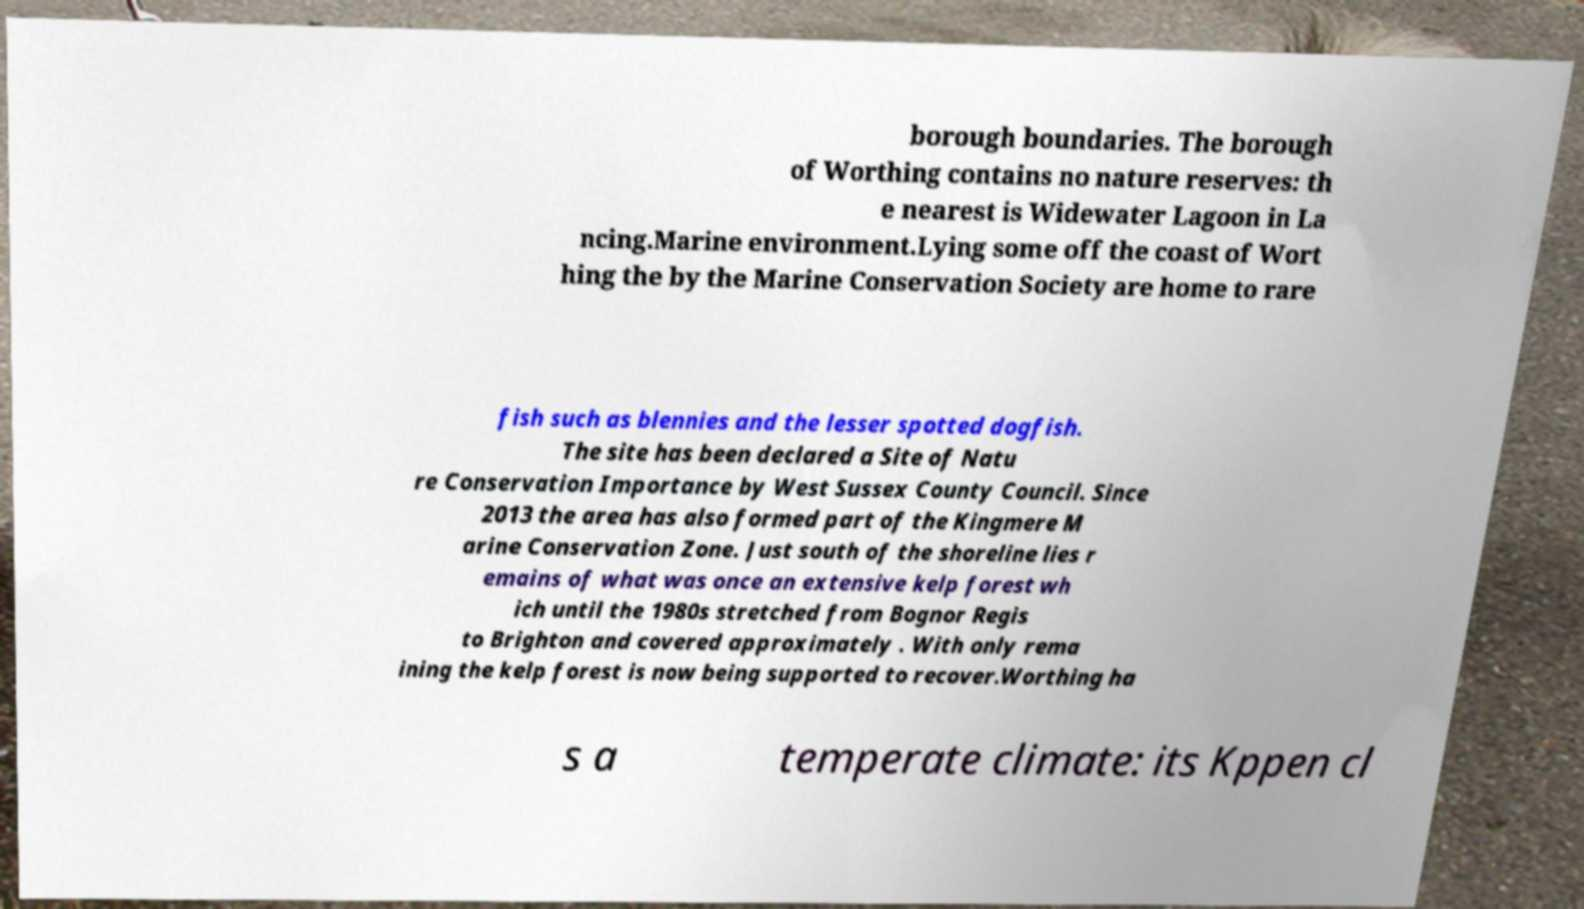There's text embedded in this image that I need extracted. Can you transcribe it verbatim? borough boundaries. The borough of Worthing contains no nature reserves: th e nearest is Widewater Lagoon in La ncing.Marine environment.Lying some off the coast of Wort hing the by the Marine Conservation Society are home to rare fish such as blennies and the lesser spotted dogfish. The site has been declared a Site of Natu re Conservation Importance by West Sussex County Council. Since 2013 the area has also formed part of the Kingmere M arine Conservation Zone. Just south of the shoreline lies r emains of what was once an extensive kelp forest wh ich until the 1980s stretched from Bognor Regis to Brighton and covered approximately . With only rema ining the kelp forest is now being supported to recover.Worthing ha s a temperate climate: its Kppen cl 